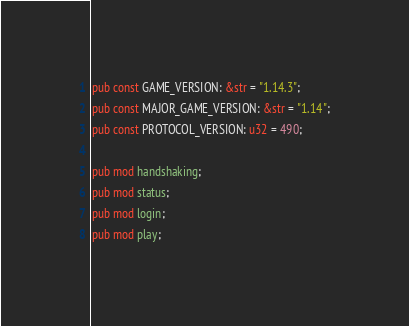Convert code to text. <code><loc_0><loc_0><loc_500><loc_500><_Rust_>pub const GAME_VERSION: &str = "1.14.3";
pub const MAJOR_GAME_VERSION: &str = "1.14";
pub const PROTOCOL_VERSION: u32 = 490;

pub mod handshaking;
pub mod status;
pub mod login;
pub mod play;
</code> 